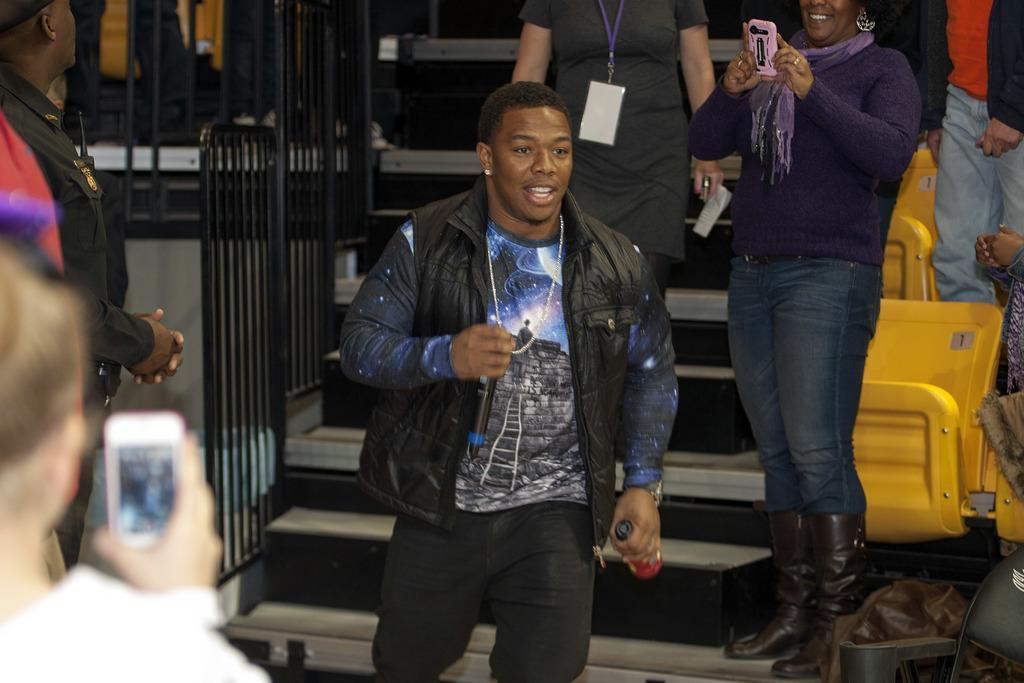In one or two sentences, can you explain what this image depicts? In this image we can see a person holding a mic and a bottle walking down stairs. We can also see some people standing beside him holding the cell phones. 